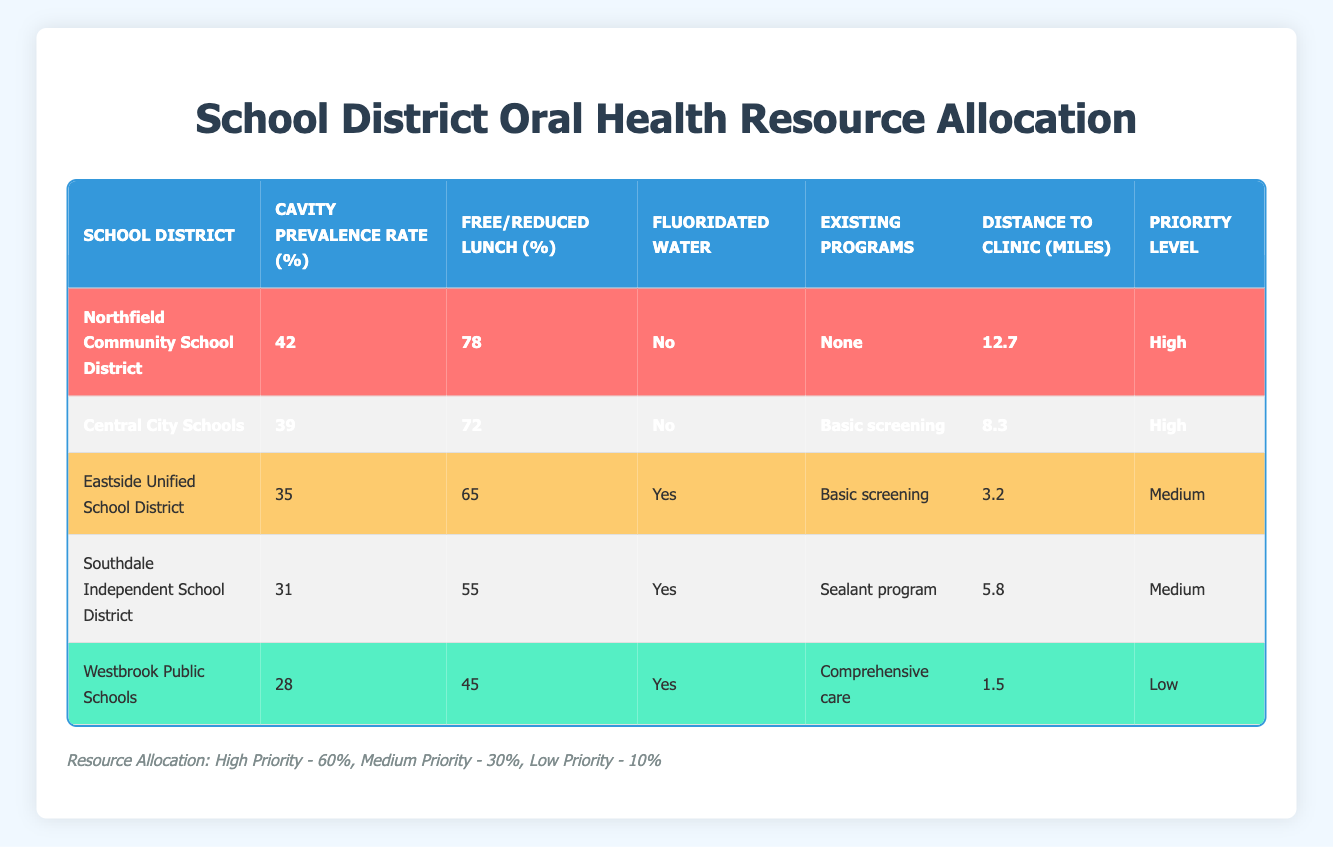What is the cavity prevalence rate for Northfield Community School District? The cavity prevalence rate for Northfield Community School District is located in the table, specifically in the column labeled "Cavity Prevalence Rate (%)". The corresponding value in the same row is 42.
Answer: 42 Which school district has the highest percentage of students eligible for free/reduced lunch? To find this, I compare the values in the "Free/Reduced Lunch (%)" column. Northfield Community School District has the highest value at 78%.
Answer: Northfield Community School District Does Westbrook Public Schools have access to fluoridated water? The table indicates whether each district has access to fluoridated water in the "Fluoridated Water" column. For Westbrook Public Schools, the corresponding value is "Yes."
Answer: Yes What is the average distance to the nearest dental clinic for all school districts? To determine the average distance, I sum the distances listed in the "Distance to Clinic (miles)" column: (3.2 + 1.5 + 12.7 + 5.8 + 8.3) = 31.5 miles. Then, I divide this sum by the number of districts (5) to get the average: 31.5 / 5 = 6.3 miles.
Answer: 6.3 miles Which two districts have the highest priority level? The priority levels are listed under the "Priority Level" column. The two districts with the highest priority levels are Northfield Community School District and Central City Schools, both classified as "High."
Answer: Northfield Community School District and Central City Schools What percentage of resources will be allocated to Medium priority schools? According to the resource allocation information at the bottom of the table, Medium priority schools will receive 30% of the resources.
Answer: 30% Is there any school district with no existing programs? I check the "Existing Programs" column for the mention of "None". The data shows that Northfield Community School District has "None," indicating that it does not have any existing programs.
Answer: Yes What is the percentage difference in cavity prevalence between Eastside Unified School District and Central City Schools? The cavity prevalence rates are 35% for Eastside Unified School District and 39% for Central City Schools. The percentage difference is calculated as (39 - 35) = 4. To express this difference as a percentage relative to Eastside, it is (4 / 35) * 100 = 11.43%.
Answer: 11.43% Which district has the furthest distance to a dental clinic, and what is that distance? Looking through the "Distance to Clinic (miles)" column, I see that Northfield Community School District has the largest value, which is 12.7 miles.
Answer: Northfield Community School District, 12.7 miles 